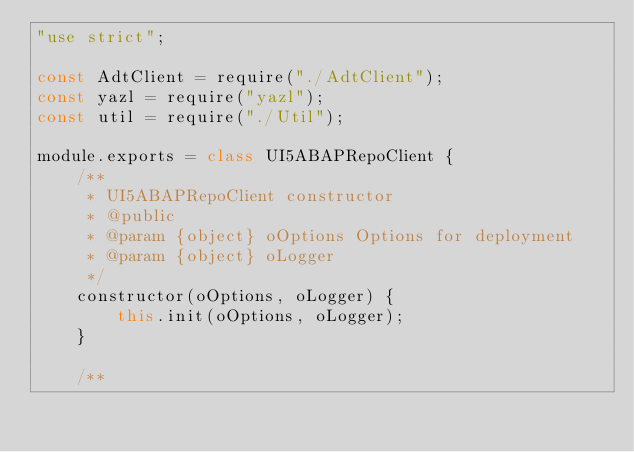<code> <loc_0><loc_0><loc_500><loc_500><_JavaScript_>"use strict";

const AdtClient = require("./AdtClient");
const yazl = require("yazl");
const util = require("./Util");

module.exports = class UI5ABAPRepoClient {
    /**
     * UI5ABAPRepoClient constructor
     * @public
     * @param {object} oOptions Options for deployment
     * @param {object} oLogger
     */
    constructor(oOptions, oLogger) {
        this.init(oOptions, oLogger);
    }

    /**</code> 